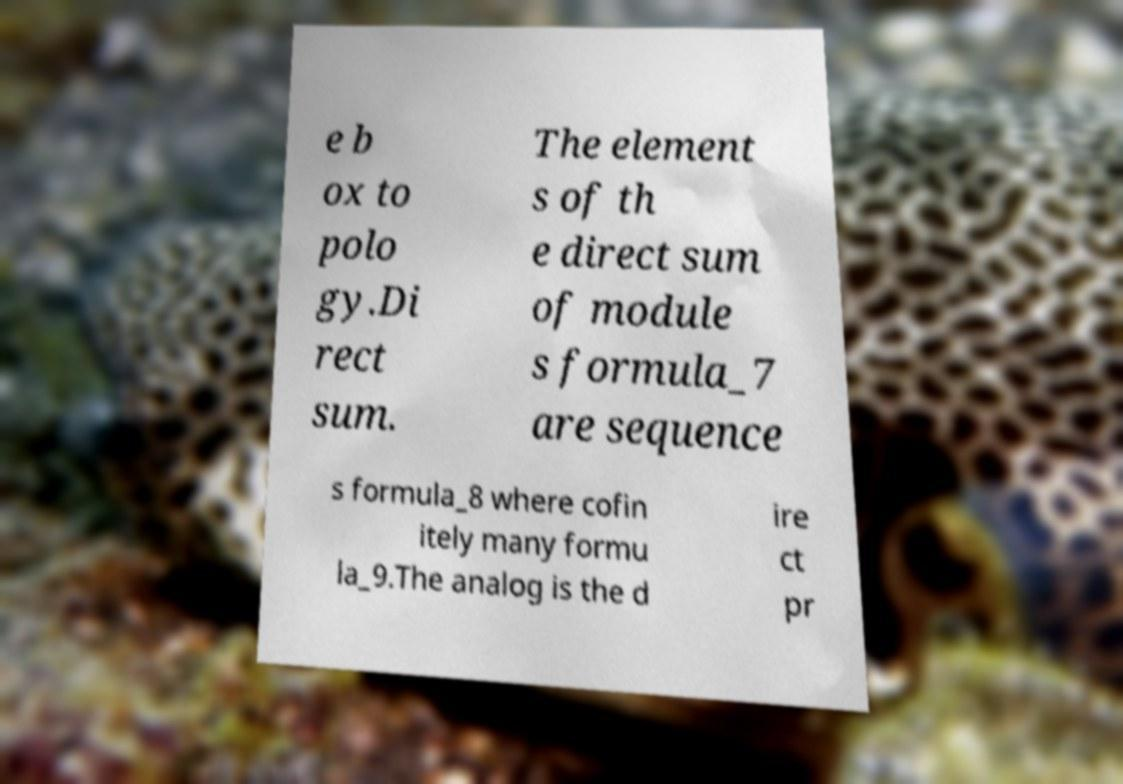What messages or text are displayed in this image? I need them in a readable, typed format. e b ox to polo gy.Di rect sum. The element s of th e direct sum of module s formula_7 are sequence s formula_8 where cofin itely many formu la_9.The analog is the d ire ct pr 